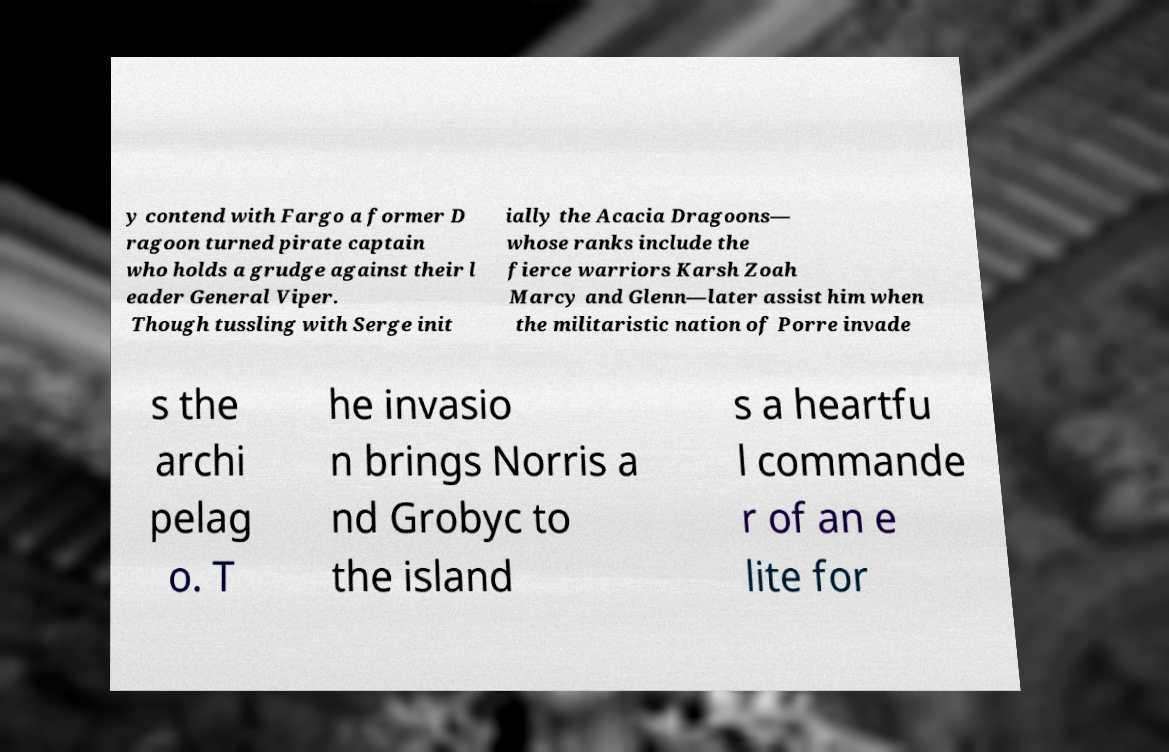What messages or text are displayed in this image? I need them in a readable, typed format. y contend with Fargo a former D ragoon turned pirate captain who holds a grudge against their l eader General Viper. Though tussling with Serge init ially the Acacia Dragoons— whose ranks include the fierce warriors Karsh Zoah Marcy and Glenn—later assist him when the militaristic nation of Porre invade s the archi pelag o. T he invasio n brings Norris a nd Grobyc to the island s a heartfu l commande r of an e lite for 